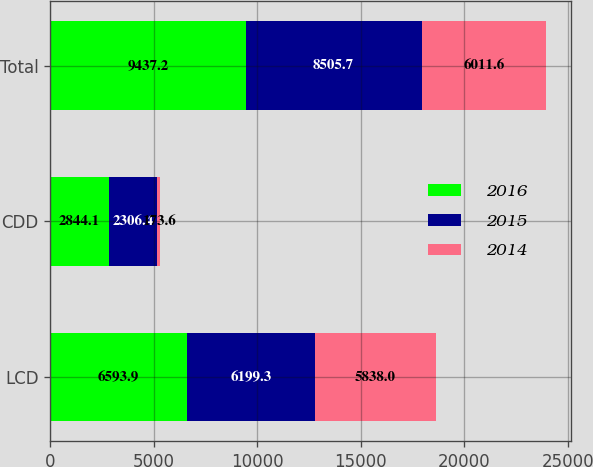Convert chart to OTSL. <chart><loc_0><loc_0><loc_500><loc_500><stacked_bar_chart><ecel><fcel>LCD<fcel>CDD<fcel>Total<nl><fcel>2016<fcel>6593.9<fcel>2844.1<fcel>9437.2<nl><fcel>2015<fcel>6199.3<fcel>2306.4<fcel>8505.7<nl><fcel>2014<fcel>5838<fcel>173.6<fcel>6011.6<nl></chart> 